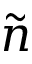Convert formula to latex. <formula><loc_0><loc_0><loc_500><loc_500>\tilde { n }</formula> 